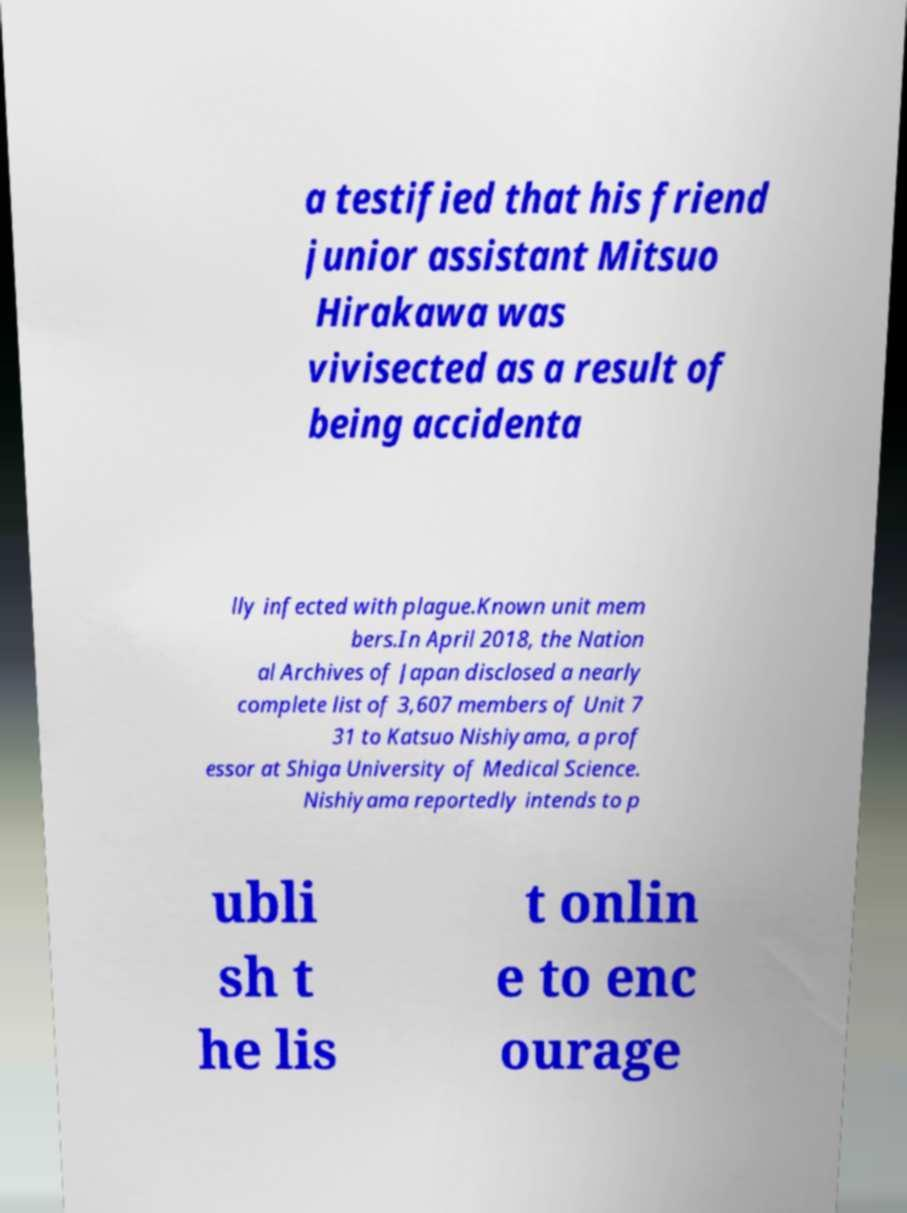Can you read and provide the text displayed in the image?This photo seems to have some interesting text. Can you extract and type it out for me? a testified that his friend junior assistant Mitsuo Hirakawa was vivisected as a result of being accidenta lly infected with plague.Known unit mem bers.In April 2018, the Nation al Archives of Japan disclosed a nearly complete list of 3,607 members of Unit 7 31 to Katsuo Nishiyama, a prof essor at Shiga University of Medical Science. Nishiyama reportedly intends to p ubli sh t he lis t onlin e to enc ourage 